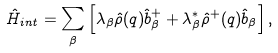<formula> <loc_0><loc_0><loc_500><loc_500>\hat { H } _ { i n t } = \sum _ { \beta } \left [ \lambda _ { \beta } \hat { \rho } ( { q } ) \hat { b } _ { \beta } ^ { + } + \lambda _ { \beta } ^ { * } \hat { \rho } ^ { + } ( { q } ) \hat { b } _ { \beta } \right ] ,</formula> 